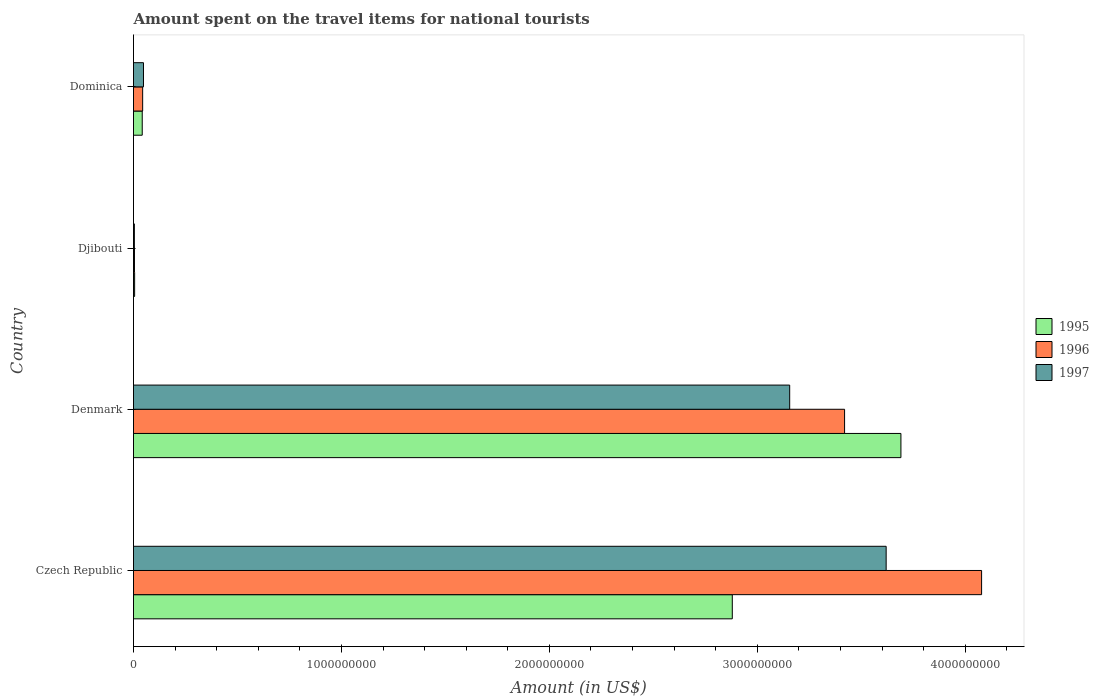Are the number of bars per tick equal to the number of legend labels?
Give a very brief answer. Yes. What is the label of the 1st group of bars from the top?
Ensure brevity in your answer.  Dominica. What is the amount spent on the travel items for national tourists in 1996 in Dominica?
Provide a succinct answer. 4.40e+07. Across all countries, what is the maximum amount spent on the travel items for national tourists in 1995?
Give a very brief answer. 3.69e+09. Across all countries, what is the minimum amount spent on the travel items for national tourists in 1997?
Provide a short and direct response. 4.20e+06. In which country was the amount spent on the travel items for national tourists in 1996 maximum?
Your answer should be compact. Czech Republic. In which country was the amount spent on the travel items for national tourists in 1996 minimum?
Give a very brief answer. Djibouti. What is the total amount spent on the travel items for national tourists in 1996 in the graph?
Offer a terse response. 7.55e+09. What is the difference between the amount spent on the travel items for national tourists in 1997 in Czech Republic and that in Dominica?
Your response must be concise. 3.57e+09. What is the difference between the amount spent on the travel items for national tourists in 1995 in Denmark and the amount spent on the travel items for national tourists in 1996 in Dominica?
Your answer should be very brief. 3.65e+09. What is the average amount spent on the travel items for national tourists in 1995 per country?
Make the answer very short. 1.65e+09. What is the difference between the amount spent on the travel items for national tourists in 1996 and amount spent on the travel items for national tourists in 1995 in Czech Republic?
Provide a succinct answer. 1.20e+09. In how many countries, is the amount spent on the travel items for national tourists in 1997 greater than 3600000000 US$?
Ensure brevity in your answer.  1. What is the ratio of the amount spent on the travel items for national tourists in 1997 in Czech Republic to that in Djibouti?
Ensure brevity in your answer.  861.9. Is the amount spent on the travel items for national tourists in 1997 in Denmark less than that in Dominica?
Provide a short and direct response. No. What is the difference between the highest and the second highest amount spent on the travel items for national tourists in 1996?
Ensure brevity in your answer.  6.59e+08. What is the difference between the highest and the lowest amount spent on the travel items for national tourists in 1995?
Make the answer very short. 3.69e+09. In how many countries, is the amount spent on the travel items for national tourists in 1996 greater than the average amount spent on the travel items for national tourists in 1996 taken over all countries?
Provide a succinct answer. 2. Is the sum of the amount spent on the travel items for national tourists in 1995 in Djibouti and Dominica greater than the maximum amount spent on the travel items for national tourists in 1997 across all countries?
Ensure brevity in your answer.  No. What does the 1st bar from the top in Djibouti represents?
Provide a succinct answer. 1997. What does the 3rd bar from the bottom in Denmark represents?
Ensure brevity in your answer.  1997. How many bars are there?
Provide a succinct answer. 12. How many countries are there in the graph?
Your response must be concise. 4. What is the difference between two consecutive major ticks on the X-axis?
Provide a succinct answer. 1.00e+09. Does the graph contain grids?
Offer a terse response. No. How are the legend labels stacked?
Keep it short and to the point. Vertical. What is the title of the graph?
Your answer should be compact. Amount spent on the travel items for national tourists. What is the label or title of the X-axis?
Make the answer very short. Amount (in US$). What is the Amount (in US$) of 1995 in Czech Republic?
Offer a very short reply. 2.88e+09. What is the Amount (in US$) of 1996 in Czech Republic?
Offer a terse response. 4.08e+09. What is the Amount (in US$) of 1997 in Czech Republic?
Your answer should be very brief. 3.62e+09. What is the Amount (in US$) in 1995 in Denmark?
Offer a very short reply. 3.69e+09. What is the Amount (in US$) of 1996 in Denmark?
Keep it short and to the point. 3.42e+09. What is the Amount (in US$) of 1997 in Denmark?
Provide a succinct answer. 3.16e+09. What is the Amount (in US$) of 1995 in Djibouti?
Give a very brief answer. 5.40e+06. What is the Amount (in US$) in 1996 in Djibouti?
Offer a terse response. 4.60e+06. What is the Amount (in US$) of 1997 in Djibouti?
Offer a terse response. 4.20e+06. What is the Amount (in US$) of 1995 in Dominica?
Offer a terse response. 4.20e+07. What is the Amount (in US$) in 1996 in Dominica?
Your answer should be compact. 4.40e+07. What is the Amount (in US$) of 1997 in Dominica?
Your answer should be compact. 4.80e+07. Across all countries, what is the maximum Amount (in US$) of 1995?
Give a very brief answer. 3.69e+09. Across all countries, what is the maximum Amount (in US$) of 1996?
Your answer should be very brief. 4.08e+09. Across all countries, what is the maximum Amount (in US$) of 1997?
Keep it short and to the point. 3.62e+09. Across all countries, what is the minimum Amount (in US$) of 1995?
Make the answer very short. 5.40e+06. Across all countries, what is the minimum Amount (in US$) in 1996?
Your answer should be compact. 4.60e+06. Across all countries, what is the minimum Amount (in US$) in 1997?
Provide a short and direct response. 4.20e+06. What is the total Amount (in US$) of 1995 in the graph?
Your response must be concise. 6.62e+09. What is the total Amount (in US$) of 1996 in the graph?
Provide a short and direct response. 7.55e+09. What is the total Amount (in US$) in 1997 in the graph?
Make the answer very short. 6.83e+09. What is the difference between the Amount (in US$) in 1995 in Czech Republic and that in Denmark?
Provide a short and direct response. -8.11e+08. What is the difference between the Amount (in US$) of 1996 in Czech Republic and that in Denmark?
Give a very brief answer. 6.59e+08. What is the difference between the Amount (in US$) of 1997 in Czech Republic and that in Denmark?
Make the answer very short. 4.64e+08. What is the difference between the Amount (in US$) in 1995 in Czech Republic and that in Djibouti?
Your response must be concise. 2.87e+09. What is the difference between the Amount (in US$) of 1996 in Czech Republic and that in Djibouti?
Keep it short and to the point. 4.07e+09. What is the difference between the Amount (in US$) in 1997 in Czech Republic and that in Djibouti?
Provide a succinct answer. 3.62e+09. What is the difference between the Amount (in US$) in 1995 in Czech Republic and that in Dominica?
Make the answer very short. 2.84e+09. What is the difference between the Amount (in US$) of 1996 in Czech Republic and that in Dominica?
Provide a short and direct response. 4.04e+09. What is the difference between the Amount (in US$) of 1997 in Czech Republic and that in Dominica?
Your answer should be very brief. 3.57e+09. What is the difference between the Amount (in US$) in 1995 in Denmark and that in Djibouti?
Provide a succinct answer. 3.69e+09. What is the difference between the Amount (in US$) in 1996 in Denmark and that in Djibouti?
Your response must be concise. 3.42e+09. What is the difference between the Amount (in US$) of 1997 in Denmark and that in Djibouti?
Give a very brief answer. 3.15e+09. What is the difference between the Amount (in US$) in 1995 in Denmark and that in Dominica?
Make the answer very short. 3.65e+09. What is the difference between the Amount (in US$) of 1996 in Denmark and that in Dominica?
Provide a short and direct response. 3.38e+09. What is the difference between the Amount (in US$) of 1997 in Denmark and that in Dominica?
Your response must be concise. 3.11e+09. What is the difference between the Amount (in US$) in 1995 in Djibouti and that in Dominica?
Provide a succinct answer. -3.66e+07. What is the difference between the Amount (in US$) in 1996 in Djibouti and that in Dominica?
Offer a terse response. -3.94e+07. What is the difference between the Amount (in US$) of 1997 in Djibouti and that in Dominica?
Provide a succinct answer. -4.38e+07. What is the difference between the Amount (in US$) in 1995 in Czech Republic and the Amount (in US$) in 1996 in Denmark?
Your response must be concise. -5.40e+08. What is the difference between the Amount (in US$) of 1995 in Czech Republic and the Amount (in US$) of 1997 in Denmark?
Ensure brevity in your answer.  -2.76e+08. What is the difference between the Amount (in US$) in 1996 in Czech Republic and the Amount (in US$) in 1997 in Denmark?
Your answer should be very brief. 9.23e+08. What is the difference between the Amount (in US$) of 1995 in Czech Republic and the Amount (in US$) of 1996 in Djibouti?
Offer a very short reply. 2.88e+09. What is the difference between the Amount (in US$) of 1995 in Czech Republic and the Amount (in US$) of 1997 in Djibouti?
Offer a terse response. 2.88e+09. What is the difference between the Amount (in US$) in 1996 in Czech Republic and the Amount (in US$) in 1997 in Djibouti?
Ensure brevity in your answer.  4.07e+09. What is the difference between the Amount (in US$) in 1995 in Czech Republic and the Amount (in US$) in 1996 in Dominica?
Your answer should be compact. 2.84e+09. What is the difference between the Amount (in US$) in 1995 in Czech Republic and the Amount (in US$) in 1997 in Dominica?
Your response must be concise. 2.83e+09. What is the difference between the Amount (in US$) in 1996 in Czech Republic and the Amount (in US$) in 1997 in Dominica?
Your response must be concise. 4.03e+09. What is the difference between the Amount (in US$) in 1995 in Denmark and the Amount (in US$) in 1996 in Djibouti?
Make the answer very short. 3.69e+09. What is the difference between the Amount (in US$) in 1995 in Denmark and the Amount (in US$) in 1997 in Djibouti?
Your answer should be very brief. 3.69e+09. What is the difference between the Amount (in US$) of 1996 in Denmark and the Amount (in US$) of 1997 in Djibouti?
Give a very brief answer. 3.42e+09. What is the difference between the Amount (in US$) in 1995 in Denmark and the Amount (in US$) in 1996 in Dominica?
Give a very brief answer. 3.65e+09. What is the difference between the Amount (in US$) of 1995 in Denmark and the Amount (in US$) of 1997 in Dominica?
Provide a succinct answer. 3.64e+09. What is the difference between the Amount (in US$) of 1996 in Denmark and the Amount (in US$) of 1997 in Dominica?
Give a very brief answer. 3.37e+09. What is the difference between the Amount (in US$) of 1995 in Djibouti and the Amount (in US$) of 1996 in Dominica?
Provide a succinct answer. -3.86e+07. What is the difference between the Amount (in US$) in 1995 in Djibouti and the Amount (in US$) in 1997 in Dominica?
Your answer should be very brief. -4.26e+07. What is the difference between the Amount (in US$) in 1996 in Djibouti and the Amount (in US$) in 1997 in Dominica?
Your response must be concise. -4.34e+07. What is the average Amount (in US$) of 1995 per country?
Provide a succinct answer. 1.65e+09. What is the average Amount (in US$) of 1996 per country?
Provide a succinct answer. 1.89e+09. What is the average Amount (in US$) of 1997 per country?
Give a very brief answer. 1.71e+09. What is the difference between the Amount (in US$) of 1995 and Amount (in US$) of 1996 in Czech Republic?
Offer a very short reply. -1.20e+09. What is the difference between the Amount (in US$) in 1995 and Amount (in US$) in 1997 in Czech Republic?
Offer a very short reply. -7.40e+08. What is the difference between the Amount (in US$) of 1996 and Amount (in US$) of 1997 in Czech Republic?
Make the answer very short. 4.59e+08. What is the difference between the Amount (in US$) in 1995 and Amount (in US$) in 1996 in Denmark?
Your answer should be very brief. 2.71e+08. What is the difference between the Amount (in US$) of 1995 and Amount (in US$) of 1997 in Denmark?
Provide a short and direct response. 5.35e+08. What is the difference between the Amount (in US$) in 1996 and Amount (in US$) in 1997 in Denmark?
Offer a terse response. 2.64e+08. What is the difference between the Amount (in US$) of 1995 and Amount (in US$) of 1997 in Djibouti?
Your response must be concise. 1.20e+06. What is the difference between the Amount (in US$) of 1995 and Amount (in US$) of 1997 in Dominica?
Offer a terse response. -6.00e+06. What is the ratio of the Amount (in US$) in 1995 in Czech Republic to that in Denmark?
Your answer should be compact. 0.78. What is the ratio of the Amount (in US$) in 1996 in Czech Republic to that in Denmark?
Provide a succinct answer. 1.19. What is the ratio of the Amount (in US$) of 1997 in Czech Republic to that in Denmark?
Offer a very short reply. 1.15. What is the ratio of the Amount (in US$) of 1995 in Czech Republic to that in Djibouti?
Provide a succinct answer. 533.33. What is the ratio of the Amount (in US$) of 1996 in Czech Republic to that in Djibouti?
Your answer should be very brief. 886.74. What is the ratio of the Amount (in US$) in 1997 in Czech Republic to that in Djibouti?
Make the answer very short. 861.9. What is the ratio of the Amount (in US$) of 1995 in Czech Republic to that in Dominica?
Your response must be concise. 68.57. What is the ratio of the Amount (in US$) of 1996 in Czech Republic to that in Dominica?
Your answer should be very brief. 92.7. What is the ratio of the Amount (in US$) in 1997 in Czech Republic to that in Dominica?
Ensure brevity in your answer.  75.42. What is the ratio of the Amount (in US$) in 1995 in Denmark to that in Djibouti?
Offer a very short reply. 683.52. What is the ratio of the Amount (in US$) in 1996 in Denmark to that in Djibouti?
Your answer should be very brief. 743.48. What is the ratio of the Amount (in US$) in 1997 in Denmark to that in Djibouti?
Offer a terse response. 751.43. What is the ratio of the Amount (in US$) in 1995 in Denmark to that in Dominica?
Give a very brief answer. 87.88. What is the ratio of the Amount (in US$) in 1996 in Denmark to that in Dominica?
Your response must be concise. 77.73. What is the ratio of the Amount (in US$) in 1997 in Denmark to that in Dominica?
Ensure brevity in your answer.  65.75. What is the ratio of the Amount (in US$) of 1995 in Djibouti to that in Dominica?
Provide a short and direct response. 0.13. What is the ratio of the Amount (in US$) in 1996 in Djibouti to that in Dominica?
Your answer should be compact. 0.1. What is the ratio of the Amount (in US$) in 1997 in Djibouti to that in Dominica?
Offer a terse response. 0.09. What is the difference between the highest and the second highest Amount (in US$) in 1995?
Provide a succinct answer. 8.11e+08. What is the difference between the highest and the second highest Amount (in US$) of 1996?
Provide a succinct answer. 6.59e+08. What is the difference between the highest and the second highest Amount (in US$) in 1997?
Offer a terse response. 4.64e+08. What is the difference between the highest and the lowest Amount (in US$) in 1995?
Ensure brevity in your answer.  3.69e+09. What is the difference between the highest and the lowest Amount (in US$) of 1996?
Offer a very short reply. 4.07e+09. What is the difference between the highest and the lowest Amount (in US$) of 1997?
Your answer should be very brief. 3.62e+09. 